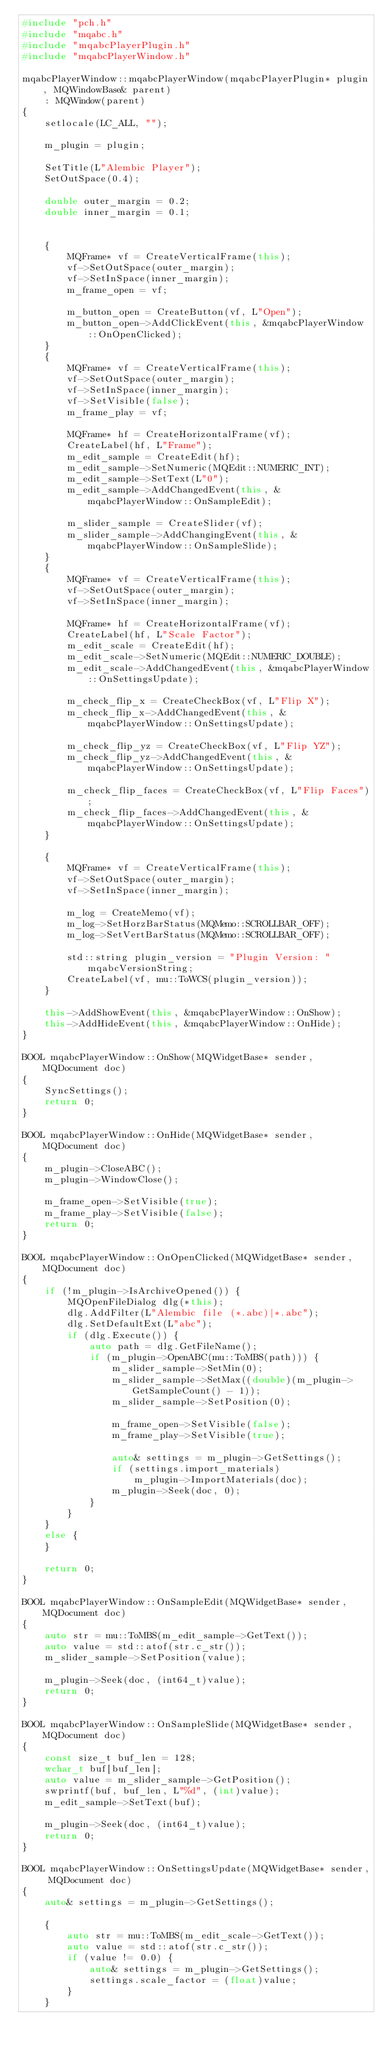<code> <loc_0><loc_0><loc_500><loc_500><_C++_>#include "pch.h"
#include "mqabc.h"
#include "mqabcPlayerPlugin.h"
#include "mqabcPlayerWindow.h"

mqabcPlayerWindow::mqabcPlayerWindow(mqabcPlayerPlugin* plugin, MQWindowBase& parent)
    : MQWindow(parent)
{
    setlocale(LC_ALL, "");

    m_plugin = plugin;

    SetTitle(L"Alembic Player");
    SetOutSpace(0.4);

    double outer_margin = 0.2;
    double inner_margin = 0.1;


    {
        MQFrame* vf = CreateVerticalFrame(this);
        vf->SetOutSpace(outer_margin);
        vf->SetInSpace(inner_margin);
        m_frame_open = vf;

        m_button_open = CreateButton(vf, L"Open");
        m_button_open->AddClickEvent(this, &mqabcPlayerWindow::OnOpenClicked);
    }
    {
        MQFrame* vf = CreateVerticalFrame(this);
        vf->SetOutSpace(outer_margin);
        vf->SetInSpace(inner_margin);
        vf->SetVisible(false);
        m_frame_play = vf;

        MQFrame* hf = CreateHorizontalFrame(vf);
        CreateLabel(hf, L"Frame");
        m_edit_sample = CreateEdit(hf);
        m_edit_sample->SetNumeric(MQEdit::NUMERIC_INT);
        m_edit_sample->SetText(L"0");
        m_edit_sample->AddChangedEvent(this, &mqabcPlayerWindow::OnSampleEdit);

        m_slider_sample = CreateSlider(vf);
        m_slider_sample->AddChangingEvent(this, &mqabcPlayerWindow::OnSampleSlide);
    }
    {
        MQFrame* vf = CreateVerticalFrame(this);
        vf->SetOutSpace(outer_margin);
        vf->SetInSpace(inner_margin);

        MQFrame* hf = CreateHorizontalFrame(vf);
        CreateLabel(hf, L"Scale Factor");
        m_edit_scale = CreateEdit(hf);
        m_edit_scale->SetNumeric(MQEdit::NUMERIC_DOUBLE);
        m_edit_scale->AddChangedEvent(this, &mqabcPlayerWindow::OnSettingsUpdate);

        m_check_flip_x = CreateCheckBox(vf, L"Flip X");
        m_check_flip_x->AddChangedEvent(this, &mqabcPlayerWindow::OnSettingsUpdate);

        m_check_flip_yz = CreateCheckBox(vf, L"Flip YZ");
        m_check_flip_yz->AddChangedEvent(this, &mqabcPlayerWindow::OnSettingsUpdate);

        m_check_flip_faces = CreateCheckBox(vf, L"Flip Faces");
        m_check_flip_faces->AddChangedEvent(this, &mqabcPlayerWindow::OnSettingsUpdate);
    }

    {
        MQFrame* vf = CreateVerticalFrame(this);
        vf->SetOutSpace(outer_margin);
        vf->SetInSpace(inner_margin);

        m_log = CreateMemo(vf);
        m_log->SetHorzBarStatus(MQMemo::SCROLLBAR_OFF);
        m_log->SetVertBarStatus(MQMemo::SCROLLBAR_OFF);

        std::string plugin_version = "Plugin Version: " mqabcVersionString;
        CreateLabel(vf, mu::ToWCS(plugin_version));
    }

    this->AddShowEvent(this, &mqabcPlayerWindow::OnShow);
    this->AddHideEvent(this, &mqabcPlayerWindow::OnHide);
}

BOOL mqabcPlayerWindow::OnShow(MQWidgetBase* sender, MQDocument doc)
{
    SyncSettings();
    return 0;
}

BOOL mqabcPlayerWindow::OnHide(MQWidgetBase* sender, MQDocument doc)
{
    m_plugin->CloseABC();
    m_plugin->WindowClose();

    m_frame_open->SetVisible(true);
    m_frame_play->SetVisible(false);
    return 0;
}

BOOL mqabcPlayerWindow::OnOpenClicked(MQWidgetBase* sender, MQDocument doc)
{
    if (!m_plugin->IsArchiveOpened()) {
        MQOpenFileDialog dlg(*this);
        dlg.AddFilter(L"Alembic file (*.abc)|*.abc");
        dlg.SetDefaultExt(L"abc");
        if (dlg.Execute()) {
            auto path = dlg.GetFileName();
            if (m_plugin->OpenABC(mu::ToMBS(path))) {
                m_slider_sample->SetMin(0);
                m_slider_sample->SetMax((double)(m_plugin->GetSampleCount() - 1));
                m_slider_sample->SetPosition(0);

                m_frame_open->SetVisible(false);
                m_frame_play->SetVisible(true);

                auto& settings = m_plugin->GetSettings();
                if (settings.import_materials)
                    m_plugin->ImportMaterials(doc);
                m_plugin->Seek(doc, 0);
            }
        }
    }
    else {
    }

    return 0;
}

BOOL mqabcPlayerWindow::OnSampleEdit(MQWidgetBase* sender, MQDocument doc)
{
    auto str = mu::ToMBS(m_edit_sample->GetText());
    auto value = std::atof(str.c_str());
    m_slider_sample->SetPosition(value);

    m_plugin->Seek(doc, (int64_t)value);
    return 0;
}

BOOL mqabcPlayerWindow::OnSampleSlide(MQWidgetBase* sender, MQDocument doc)
{
    const size_t buf_len = 128;
    wchar_t buf[buf_len];
    auto value = m_slider_sample->GetPosition();
    swprintf(buf, buf_len, L"%d", (int)value);
    m_edit_sample->SetText(buf);

    m_plugin->Seek(doc, (int64_t)value);
    return 0;
}

BOOL mqabcPlayerWindow::OnSettingsUpdate(MQWidgetBase* sender, MQDocument doc)
{
    auto& settings = m_plugin->GetSettings();

    {
        auto str = mu::ToMBS(m_edit_scale->GetText());
        auto value = std::atof(str.c_str());
        if (value != 0.0) {
            auto& settings = m_plugin->GetSettings();
            settings.scale_factor = (float)value;
        }
    }
</code> 